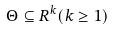Convert formula to latex. <formula><loc_0><loc_0><loc_500><loc_500>\Theta \subseteq R ^ { k } ( k \geq 1 )</formula> 